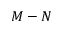<formula> <loc_0><loc_0><loc_500><loc_500>M - N</formula> 